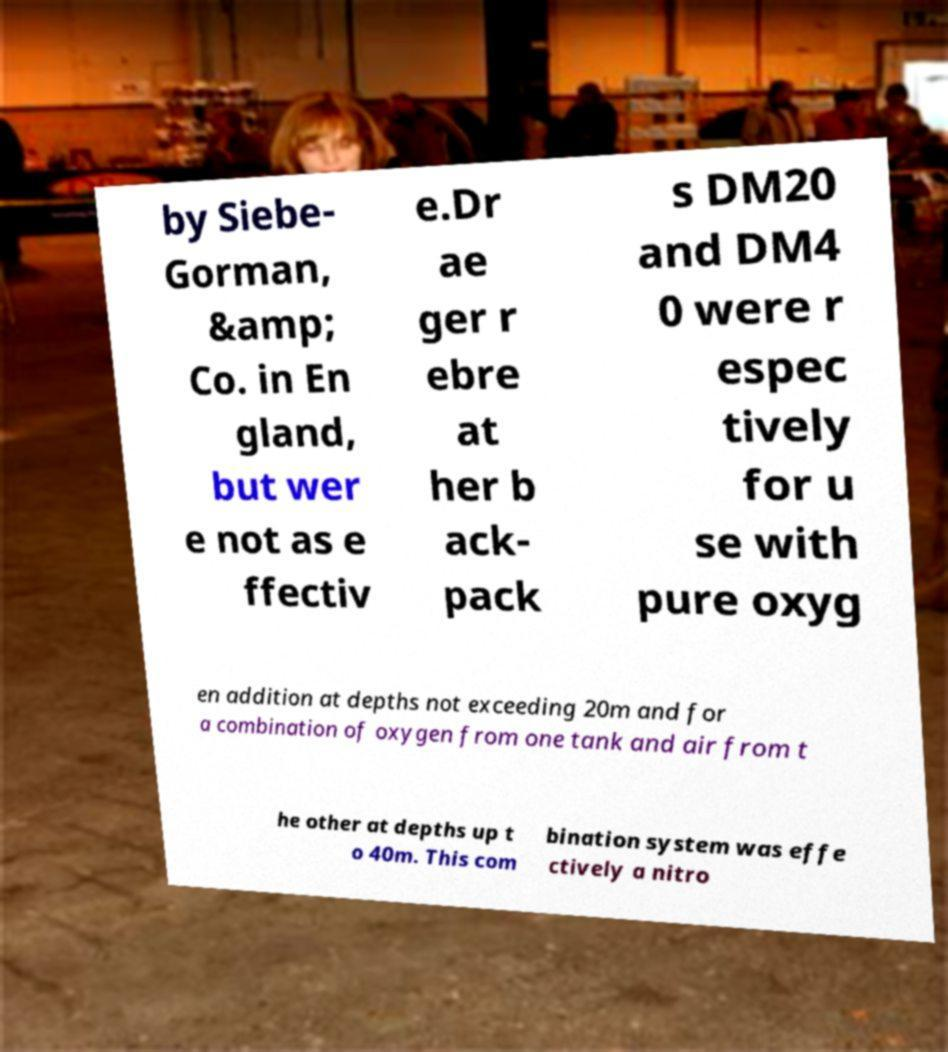Can you read and provide the text displayed in the image?This photo seems to have some interesting text. Can you extract and type it out for me? by Siebe- Gorman, &amp; Co. in En gland, but wer e not as e ffectiv e.Dr ae ger r ebre at her b ack- pack s DM20 and DM4 0 were r espec tively for u se with pure oxyg en addition at depths not exceeding 20m and for a combination of oxygen from one tank and air from t he other at depths up t o 40m. This com bination system was effe ctively a nitro 